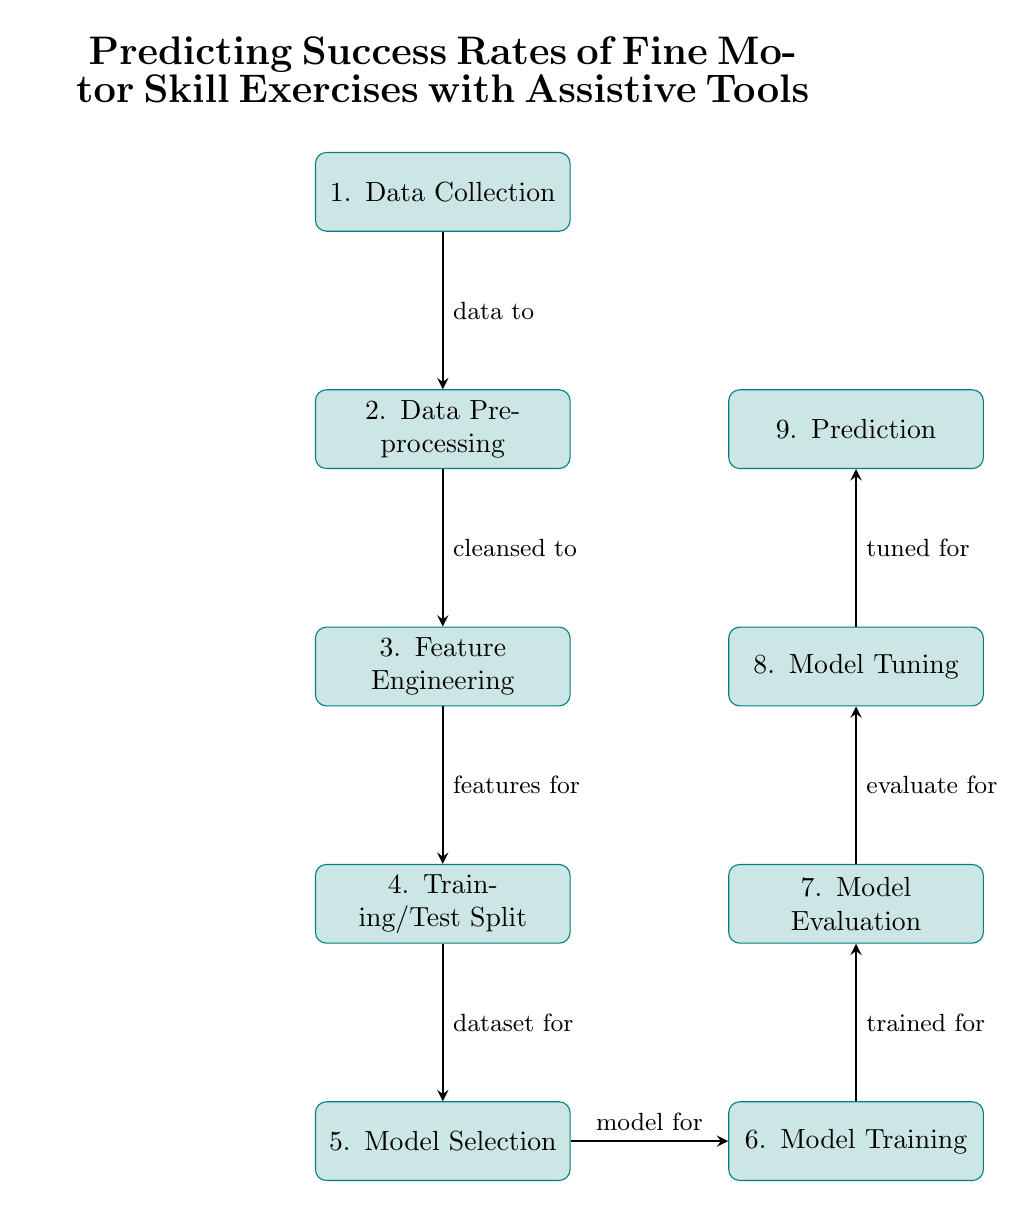What is the first step in the diagram? The first node in the diagram states "1. Data Collection," which indicates the initial action taken in the process.
Answer: Data Collection How many total steps are shown in the diagram? The diagram contains nine distinct nodes, each representing a step in the process, from Data Collection to Prediction.
Answer: Nine Which step directly precedes Model Training? The node that is immediately above "6. Model Training" is "5. Model Selection," indicating it is the step that comes before training the model.
Answer: Model Selection What type of model is being referenced in this diagram? The diagram refers specifically to regression models in the context of predicting success rates for exercises using assistive tools.
Answer: Regression Models What is the last step in the predictive process? The final node indicates "9. Prediction," which signifies the concluding action of the entire process, showing the ultimate outcome after the previous steps.
Answer: Prediction How does the data flow from Data Preprocessing to Feature Engineering? The arrow connecting "2. Data Preprocessing" to "3. Feature Engineering" indicates that the cleansed data flows into feature engineering, implying that the preprocessed data is transformed into relevant features for analysis.
Answer: Cleansed data What is the significance of the Model Evaluation step? The step "7. Model Evaluation" is crucial as it precedes model tuning, indicating that the model's performance is assessed before any adjustments are made to improve accuracy.
Answer: Assess performance Which process follows Model Tuning? The node that follows "8. Model Tuning" is "9. Prediction," meaning that once tuning is complete, prediction is the next step in the process.
Answer: Prediction What direction do the arrows in the diagram point? The arrows in the diagram consistently point downward or rightward, demonstrating the sequential and directional flow of processes from one step to the next.
Answer: Downward and rightward 